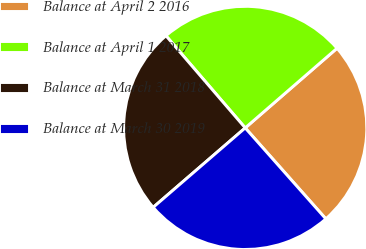Convert chart to OTSL. <chart><loc_0><loc_0><loc_500><loc_500><pie_chart><fcel>Balance at April 2 2016<fcel>Balance at April 1 2017<fcel>Balance at March 31 2018<fcel>Balance at March 30 2019<nl><fcel>24.83%<fcel>24.93%<fcel>25.03%<fcel>25.21%<nl></chart> 